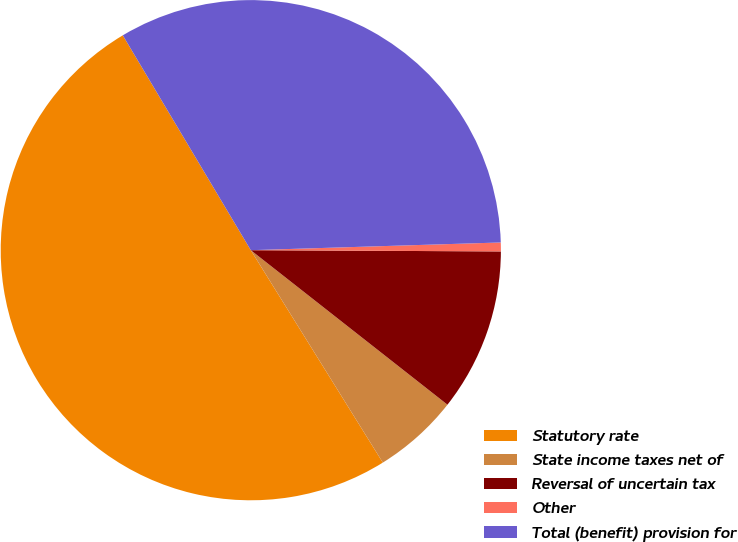Convert chart to OTSL. <chart><loc_0><loc_0><loc_500><loc_500><pie_chart><fcel>Statutory rate<fcel>State income taxes net of<fcel>Reversal of uncertain tax<fcel>Other<fcel>Total (benefit) provision for<nl><fcel>50.3%<fcel>5.55%<fcel>10.52%<fcel>0.57%<fcel>33.06%<nl></chart> 